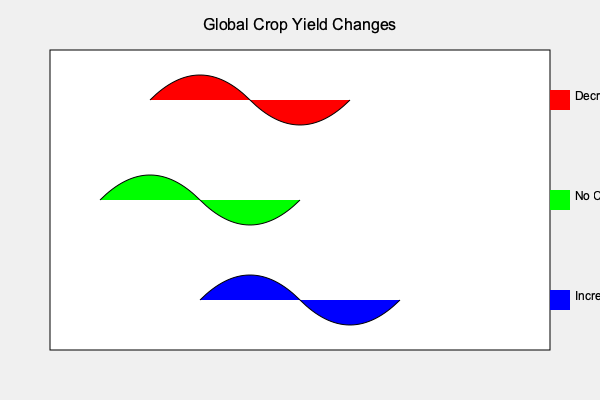Based on the world map showing crop yield changes, which region is experiencing the most significant increase in crop yields, and how might this impact global food distribution patterns? To answer this question, let's analyze the map step-by-step:

1. The map shows three color-coded regions indicating crop yield changes:
   - Red: Decrease in crop yields
   - Green: No change in crop yields
   - Blue: Increase in crop yields

2. The blue region, representing an increase in crop yields, is located in the southern part of the map and appears to be the largest area.

3. This significant increase in crop yields in the southern region could impact global food distribution patterns in several ways:

   a) Increased supply: The region with higher crop yields will likely have a surplus of food products to export.
   
   b) Price fluctuations: An increase in supply from this region may lead to lower prices for certain crops in the global market.
   
   c) Shift in trade routes: As an international food and beverage distributor, you may need to adjust your supply chain to accommodate the increased production from this southern region.
   
   d) Competition: Other regions, especially those experiencing decreased yields (red areas), may face increased competition from the southern region's products.
   
   e) Food security: The increased production in the southern region could help offset shortages in other areas, potentially improving global food security.

4. As a distributor, you would need to consider:
   - Establishing new partnerships with producers in the southern region
   - Adapting your logistics and transportation networks to handle increased volume from this area
   - Reassessing your pricing strategies to remain competitive in light of potential market changes
Answer: Southern region; increased supply, price changes, and shifts in trade routes. 